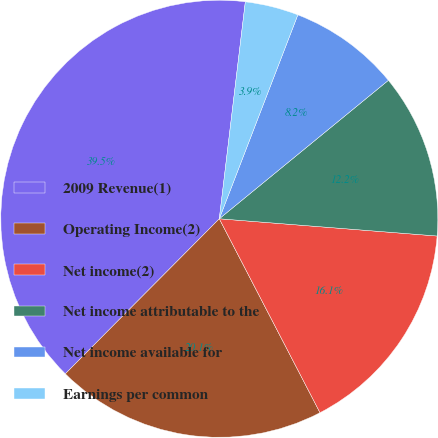Convert chart to OTSL. <chart><loc_0><loc_0><loc_500><loc_500><pie_chart><fcel>2009 Revenue(1)<fcel>Operating Income(2)<fcel>Net income(2)<fcel>Net income attributable to the<fcel>Net income available for<fcel>Earnings per common<nl><fcel>39.46%<fcel>20.07%<fcel>16.12%<fcel>12.18%<fcel>8.23%<fcel>3.95%<nl></chart> 